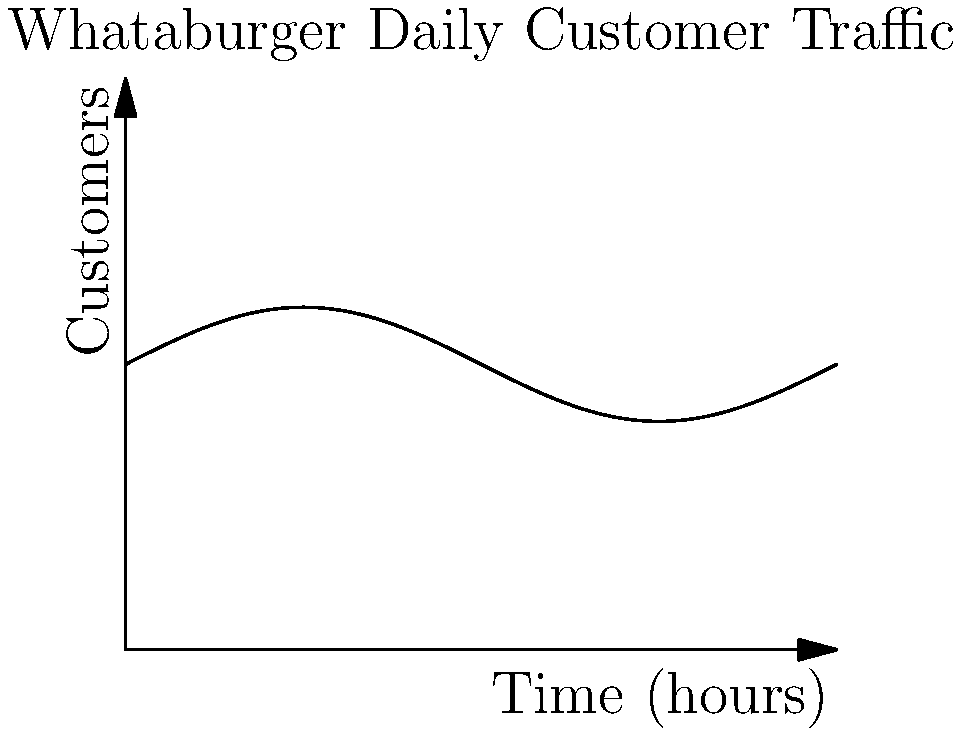The graph above represents the daily customer traffic at a Whataburger restaurant in Texas. If the function modeling this traffic is given by $f(t) = 50 + 10\sin(\frac{\pi t}{12})$, where $t$ is the time in hours since midnight, at what time is the rate of change of customer traffic the highest? To find the time when the rate of change of customer traffic is highest, we need to follow these steps:

1) The rate of change is represented by the derivative of the function. Let's find $f'(t)$:

   $f'(t) = 10 \cdot \frac{\pi}{12} \cos(\frac{\pi t}{12})$

2) The rate of change will be highest when $f'(t)$ is at its maximum value. This occurs when $\cos(\frac{\pi t}{12})$ is at its maximum, which is 1.

3) $\cos(\frac{\pi t}{12}) = 1$ when $\frac{\pi t}{12} = 2\pi n$, where $n$ is an integer.

4) Solving for $t$:
   $t = 24n$, where $n$ is an integer

5) Since we're looking at a 24-hour period, the relevant solution is when $n = 0$, which gives us $t = 0$.

6) $t = 0$ corresponds to midnight in our time scale.

Therefore, the rate of change of customer traffic is highest at midnight.
Answer: Midnight (0:00) 